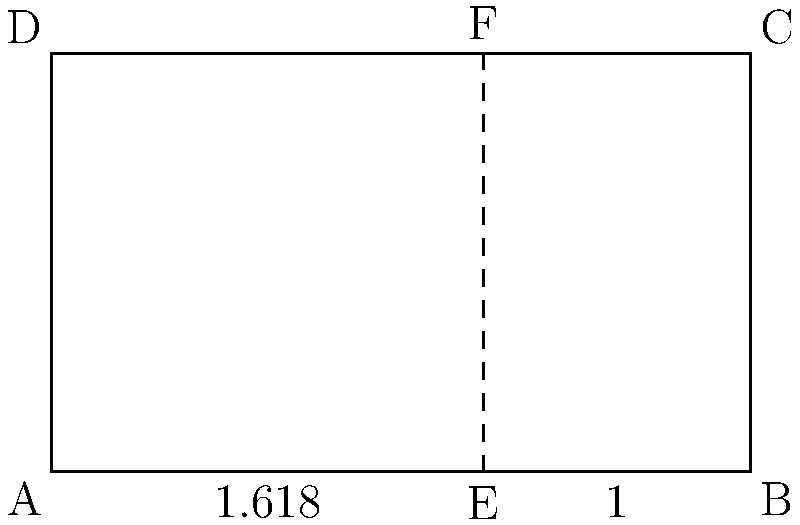In the rectangular logo design shown above, the vertical line EF divides the rectangle according to the golden ratio. If the width of the rectangle is 5 units, what is the length of segment AE to the nearest hundredth? To find the length of segment AE, we can follow these steps:

1. Recall that the golden ratio is approximately 1.618:1.

2. The total width of the rectangle is 5 units, which represents the whole (1.618 + 1 = 2.618 parts).

3. Set up a proportion:
   $\frac{\text{AE}}{\text{AB}} = \frac{1.618}{2.618}$

4. Substitute the known values:
   $\frac{\text{AE}}{5} = \frac{1.618}{2.618}$

5. Cross multiply:
   $2.618 \times \text{AE} = 5 \times 1.618$

6. Solve for AE:
   $\text{AE} = \frac{5 \times 1.618}{2.618} \approx 3.09$

7. Round to the nearest hundredth:
   $\text{AE} \approx 3.09$ units
Answer: 3.09 units 